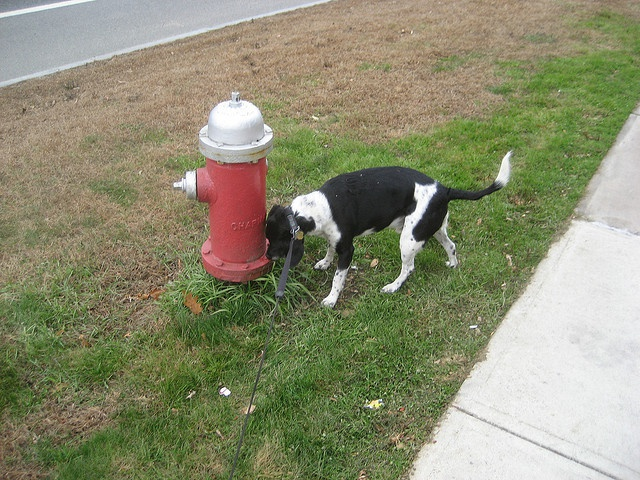Describe the objects in this image and their specific colors. I can see dog in gray, black, lightgray, and darkgray tones and fire hydrant in gray, brown, lightgray, and darkgray tones in this image. 